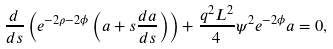Convert formula to latex. <formula><loc_0><loc_0><loc_500><loc_500>\frac { d } { d s } \left ( e ^ { - 2 \rho - 2 \phi } \left ( a + s \frac { d a } { d s } \right ) \right ) + \frac { q ^ { 2 } L ^ { 2 } } { 4 } \psi ^ { 2 } e ^ { - 2 \phi } a = 0 ,</formula> 